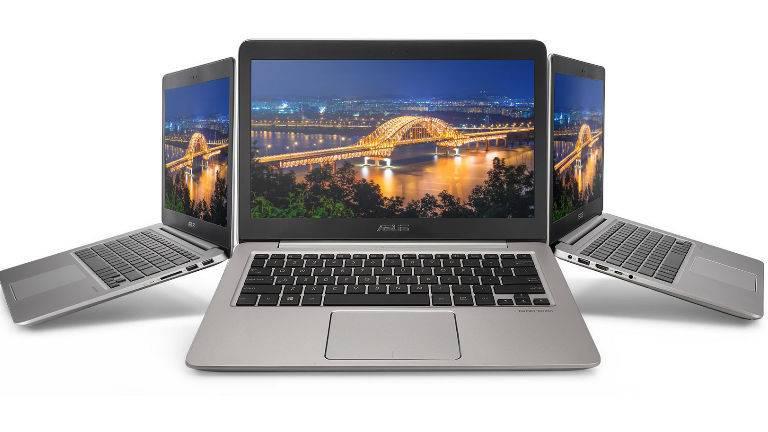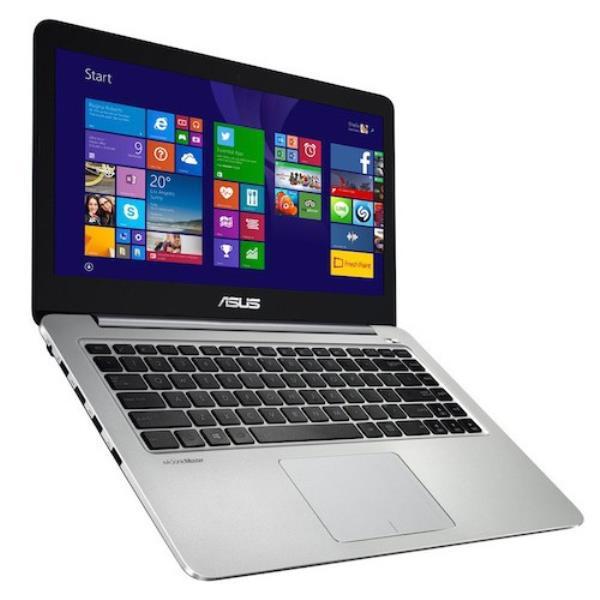The first image is the image on the left, the second image is the image on the right. Given the left and right images, does the statement "In at least one image there is a single laptop with a blue full screen touch menu." hold true? Answer yes or no. Yes. The first image is the image on the left, the second image is the image on the right. For the images displayed, is the sentence "There are at least 3 laptops in the image on the left." factually correct? Answer yes or no. Yes. 